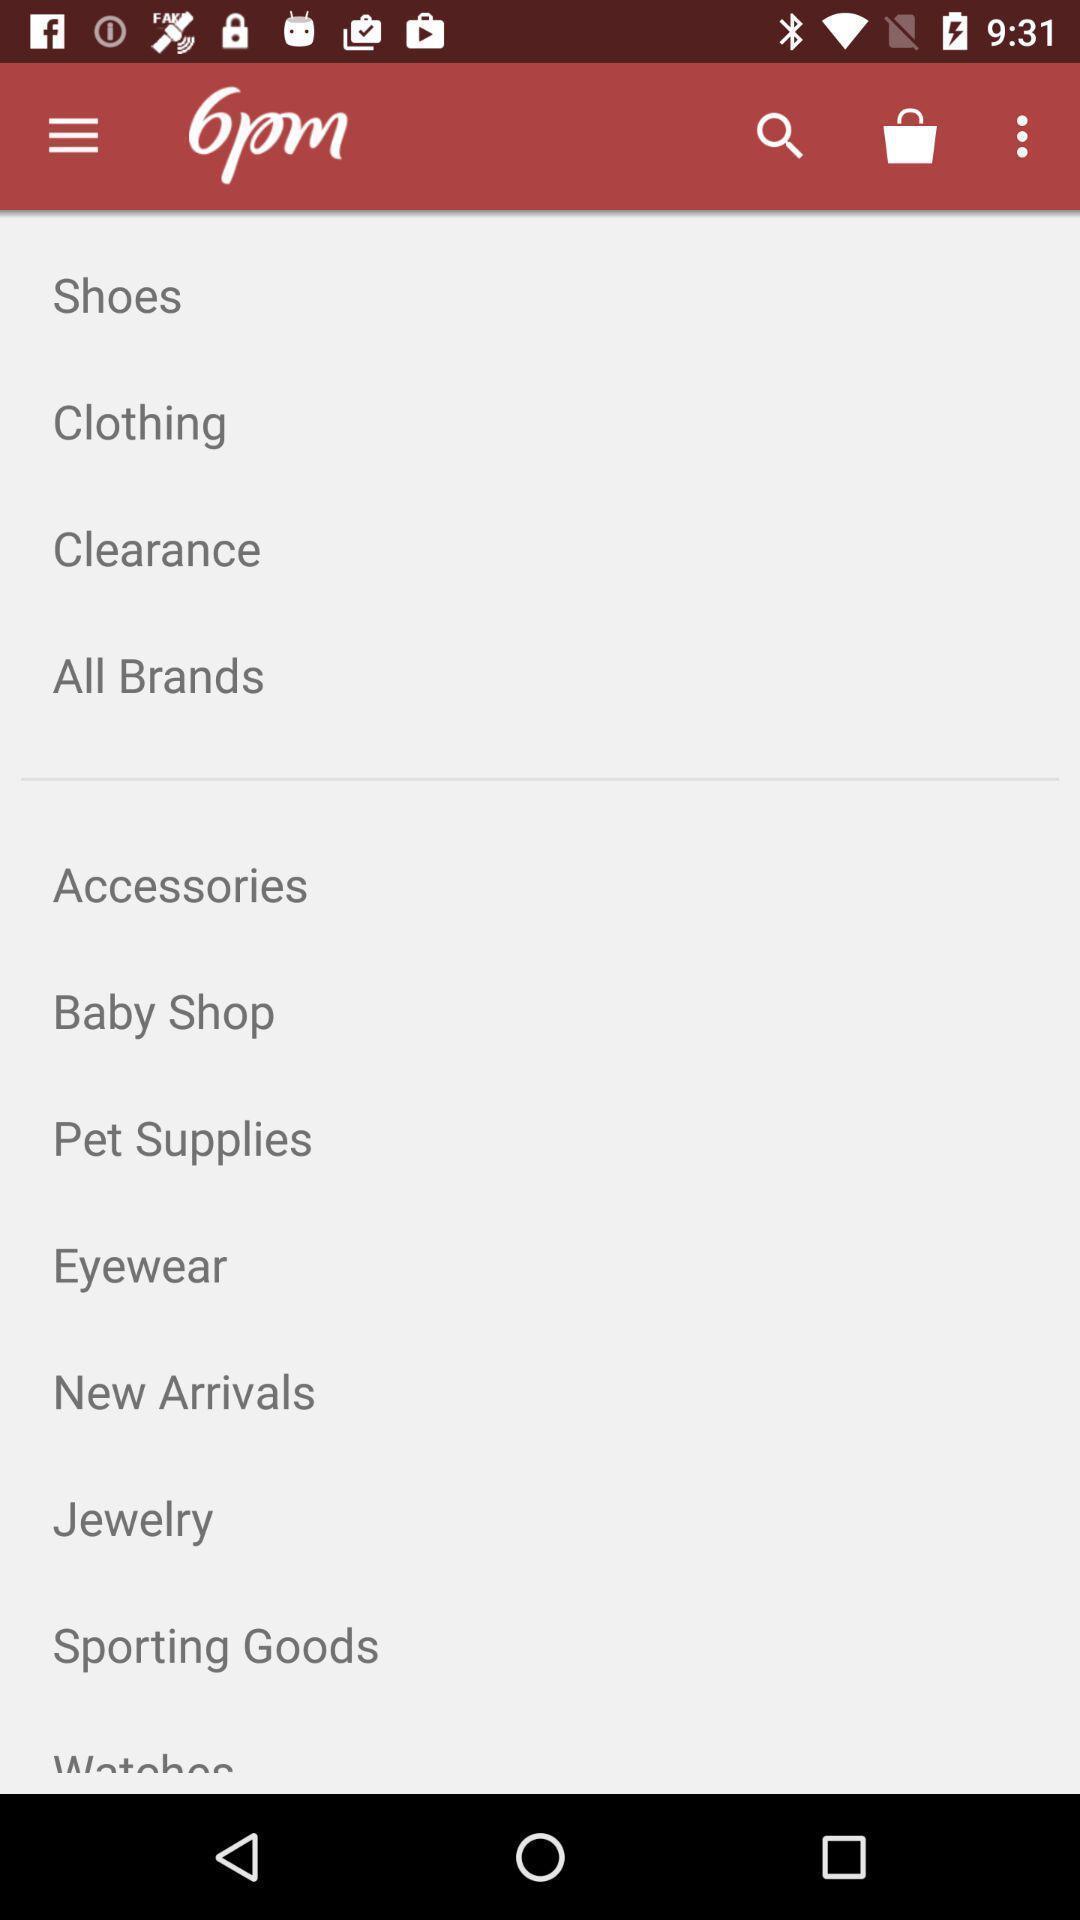Explain what's happening in this screen capture. Screen displaying the list of categories. 